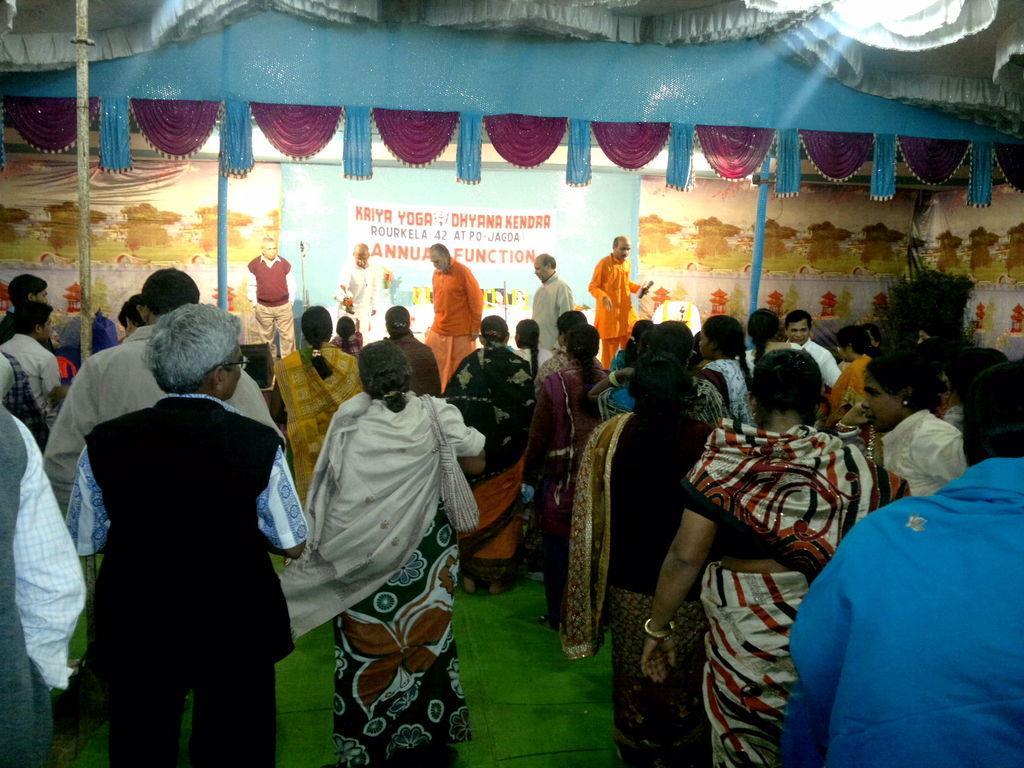Can you describe this image briefly? As we can see in the image there are few people here and there, mat, banner and a wall. 